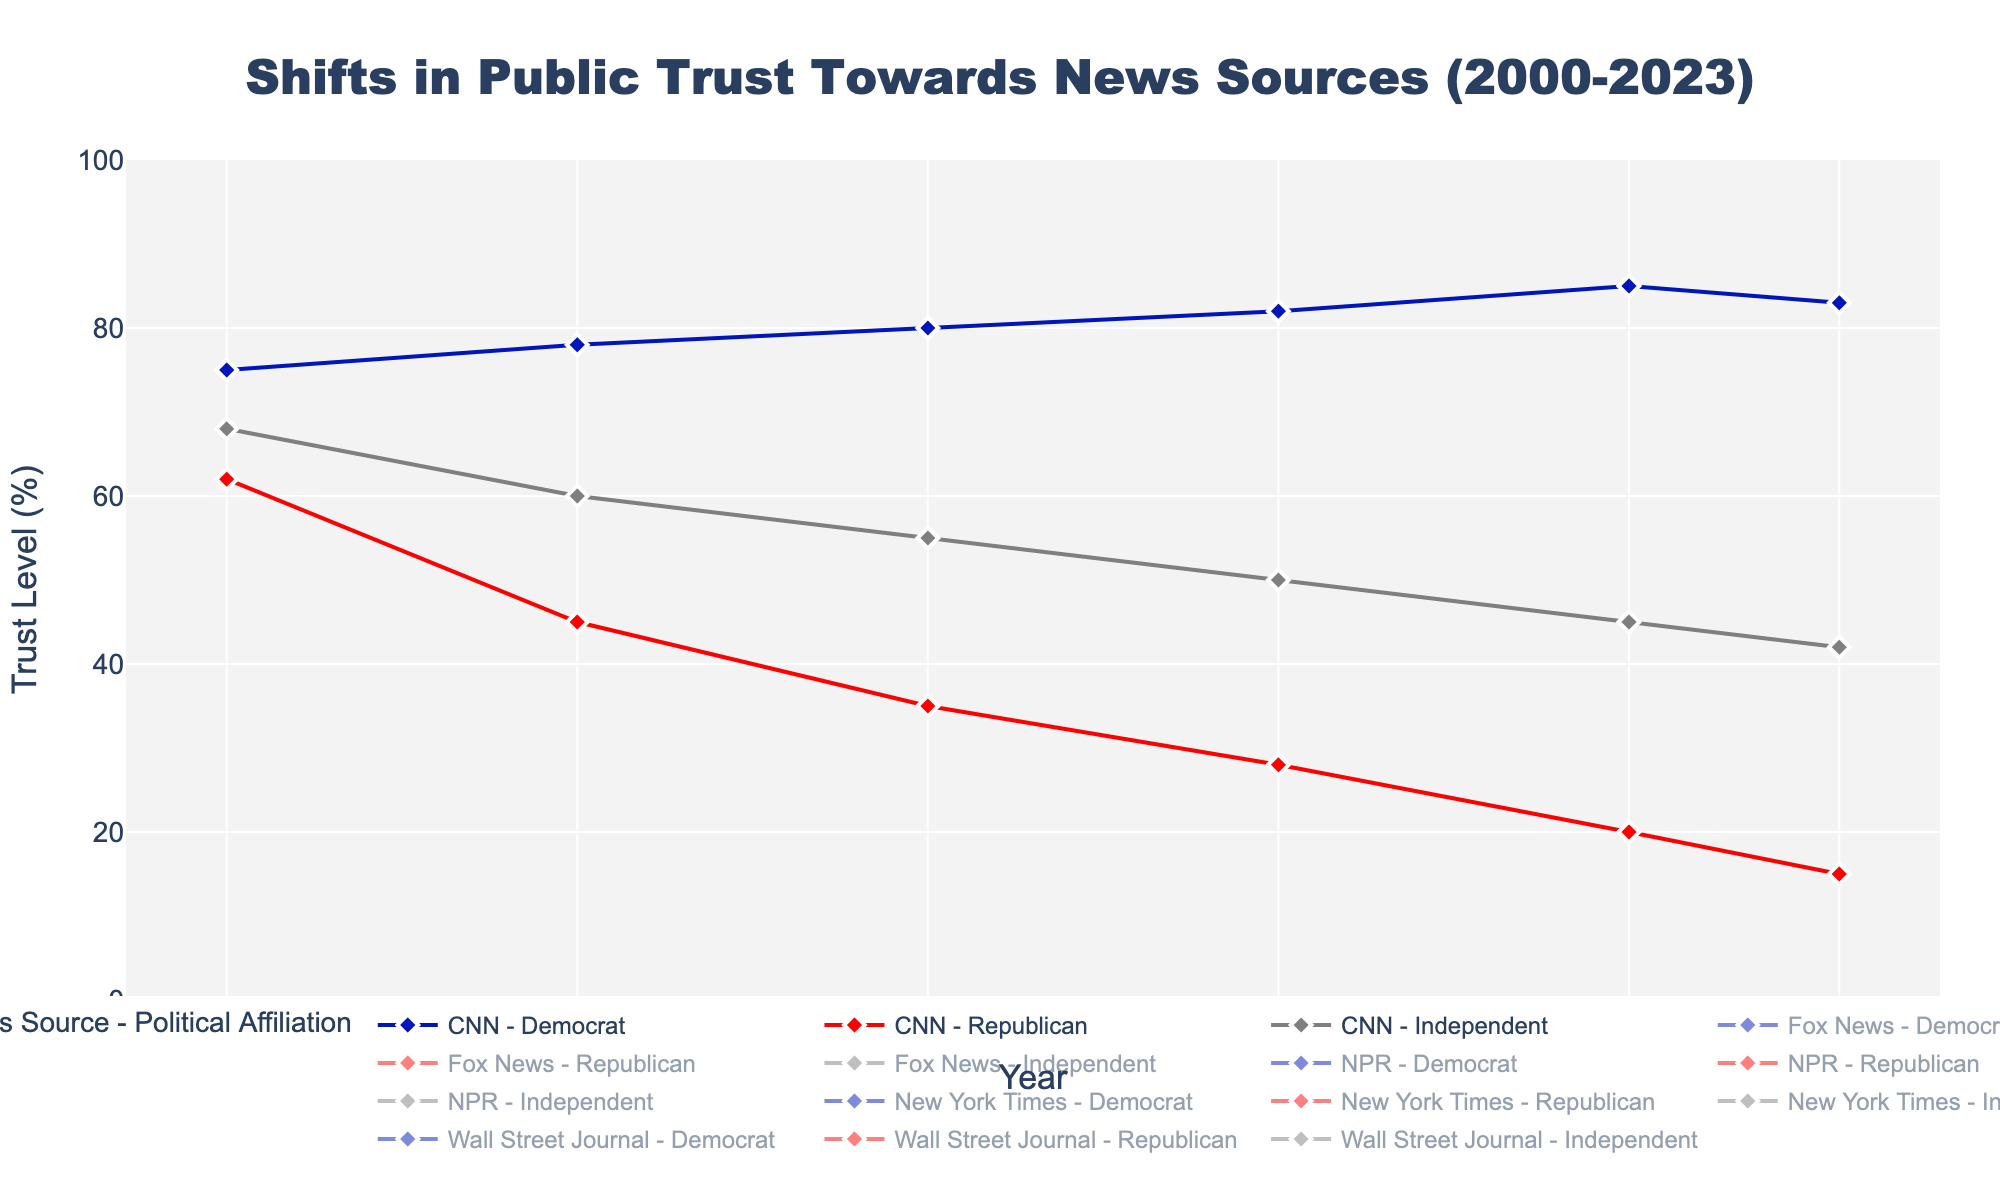What's the trend in the trust level of CNN among Democrats from 2000 to 2023? Look at the line representing CNN for Democrats. Starting at 75% in 2000, it consistently increases to 78% in 2005, 80% in 2010, 82% in 2015, reaches a peak at 85% in 2020, and slightly drops to 83% in 2023.
Answer: Generally increasing Which news source do Republicans trust the least in 2023, and what is the trust level? Find the lowest trust level among Republicans in 2023. CNN has the lowest trust level at 15%.
Answer: CNN, 15% By how much did trust in Fox News change for Independents from 2000 to 2023? In 2000, Independents had a 60% trust in Fox News. By 2023, this dropped to 35%. The change is 60% - 35% = 25%.
Answer: 25% Compare the trust levels of NPR by Democrats and Republicans in 2023. Which group trusts it more and by how much? Check the values for NPR in 2023 for both groups. Democrats have a trust level of 84%, and Republicans have 22%. The difference is 84% - 22% = 62%.
Answer: Democrats by 62% What is the average trust level across all affiliations for the New York Times in 2023? Calculate the average of trust levels for Democrats (90%), Republicans (25%), and Independents (55%). (90 + 25 + 55) / 3 = 56.67%.
Answer: 56.67% Identify the period during which trust in Wall Street Journal consistently increased or remained stable among Republicans from 2000 to 2023. Review the line for Wall Street Journal among Republicans. It increased from 70% in 2000 to 75% in 2005, 78% in 2010, 80% in 2015, 82% in 2020, and 84% in 2023. This trend is consistent.
Answer: 2000 to 2023 Which group had the largest drop in trust for CNN between 2000 and 2023? Compare the changes for all groups. Republicans trusted CNN 62% in 2000 and only 15% in 2023, a drop of 47%. This is the largest drop compared to other groups for CNN.
Answer: Republicans In which year did Democrats have the highest trust level in the New York Times, and what was it? Find the highest point on the line for Democrats with respect to the New York Times. The highest trust level is 90% in 2023.
Answer: 2023, 90% How did trust in Fox News among Republicans change from 2015 to 2020? Look at the values for Republicans' trust in Fox News. It was 88% in 2015 and increased to 90% in 2020, showing an increase.
Answer: Increased What's the trend in the trust level of NPR among Independents from 2000 to 2023? Review the line for NPR among Independents. It started at 58% in 2000, oscillated slightly but generally increased to 72% in 2023.
Answer: Generally increasing 